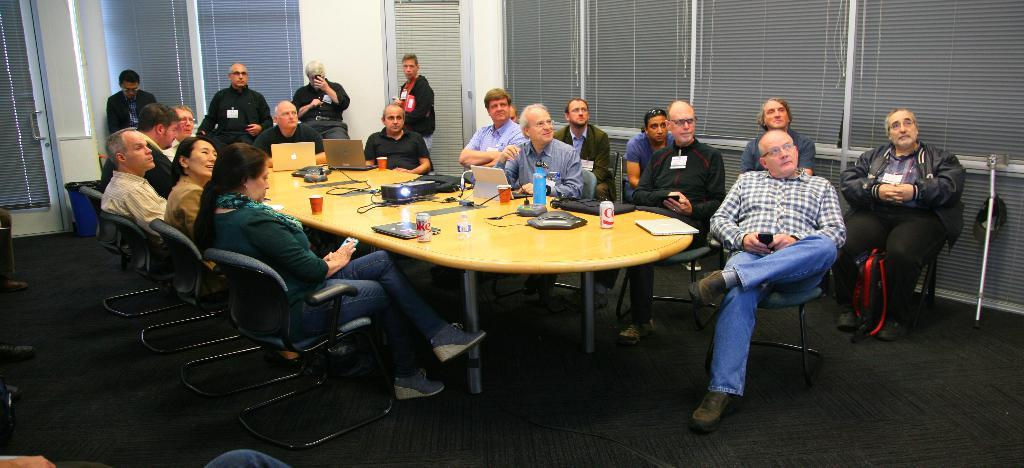What are the persons in the image doing? There are persons sitting on a chair and standing far from the sitting persons. What can be seen on the table in the image? There are laptops, a tin, a bottle, caps, and a projector on the table. How many laptops are on the table? There are two laptops on the table. What type of sound can be heard coming from the advertisement in the image? There is no advertisement present in the image, so it's not possible to determine what, if any, sound might be heard. 